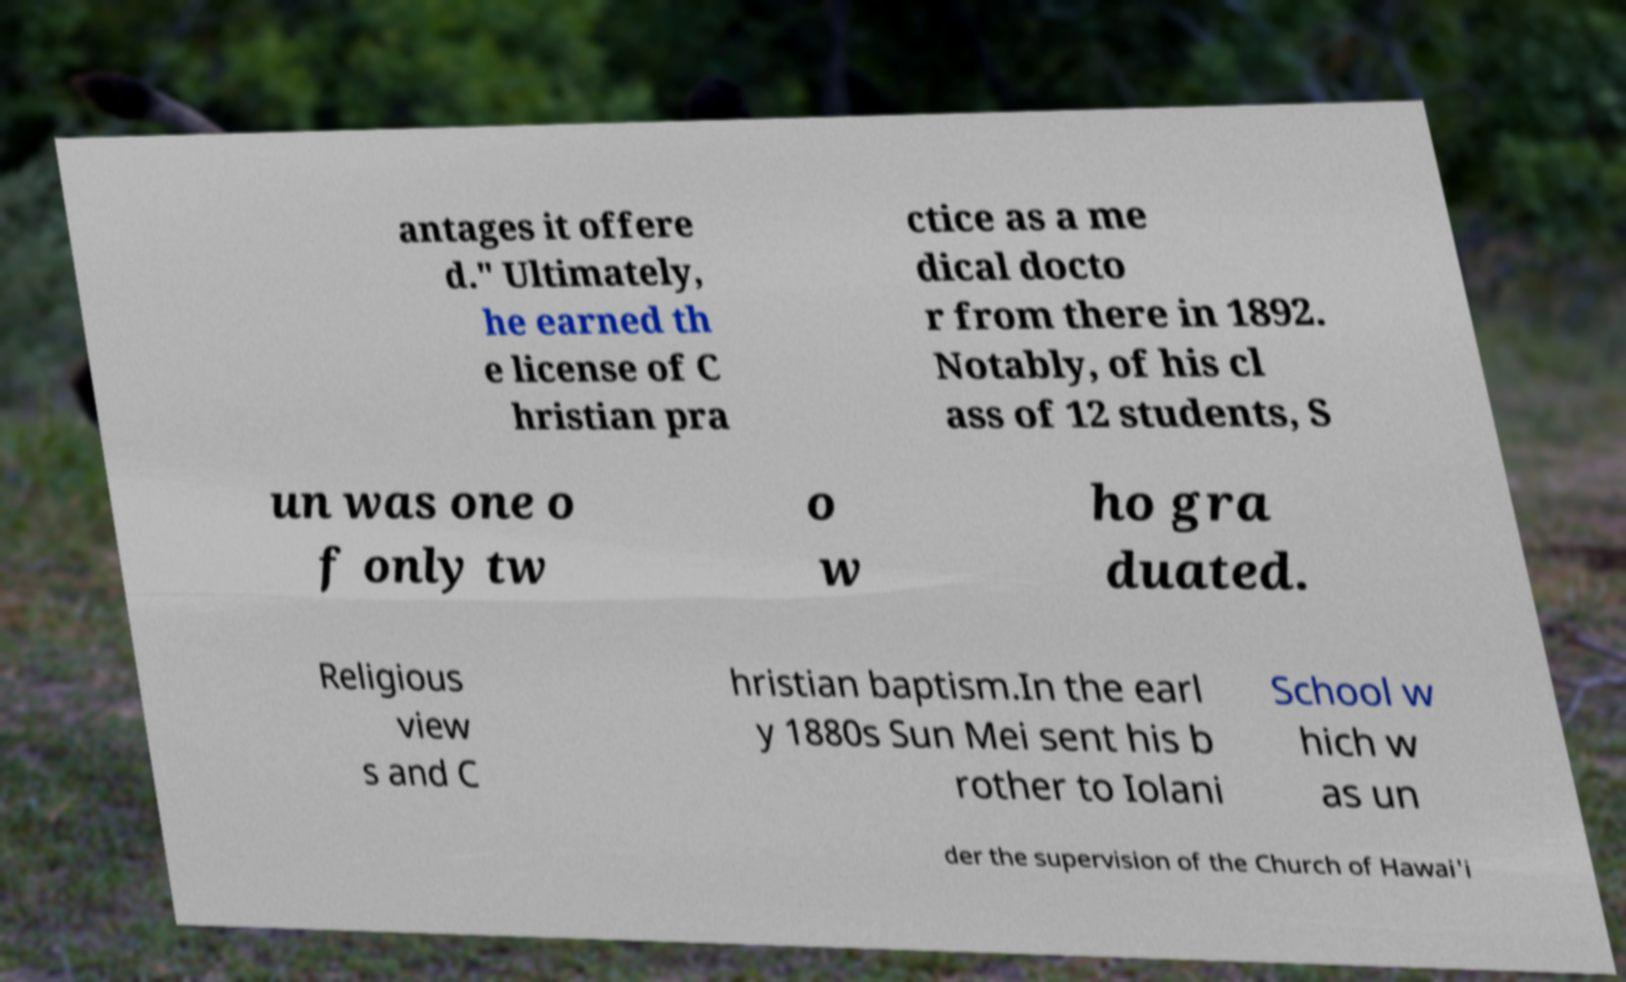Could you extract and type out the text from this image? antages it offere d." Ultimately, he earned th e license of C hristian pra ctice as a me dical docto r from there in 1892. Notably, of his cl ass of 12 students, S un was one o f only tw o w ho gra duated. Religious view s and C hristian baptism.In the earl y 1880s Sun Mei sent his b rother to Iolani School w hich w as un der the supervision of the Church of Hawai'i 